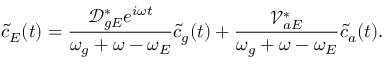Convert formula to latex. <formula><loc_0><loc_0><loc_500><loc_500>\tilde { c } _ { E } ( t ) = \frac { \mathcal { D } _ { g E } ^ { * } e ^ { i \omega t } } { \omega _ { g } + \omega - \omega _ { E } } \tilde { c } _ { g } ( t ) + \frac { \mathcal { V } _ { a E } ^ { * } } { \omega _ { g } + \omega - \omega _ { E } } \tilde { c } _ { a } ( t ) .</formula> 